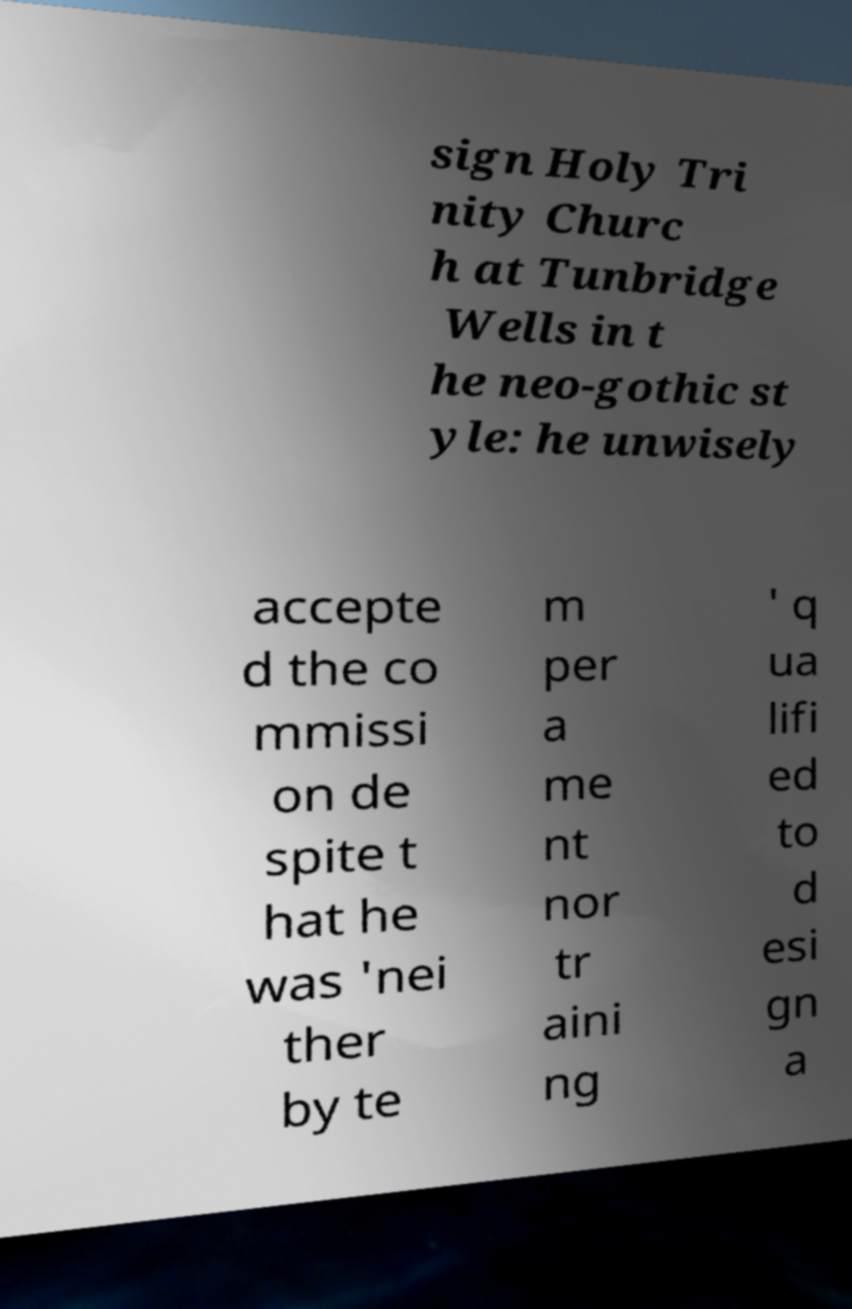What messages or text are displayed in this image? I need them in a readable, typed format. sign Holy Tri nity Churc h at Tunbridge Wells in t he neo-gothic st yle: he unwisely accepte d the co mmissi on de spite t hat he was 'nei ther by te m per a me nt nor tr aini ng ' q ua lifi ed to d esi gn a 